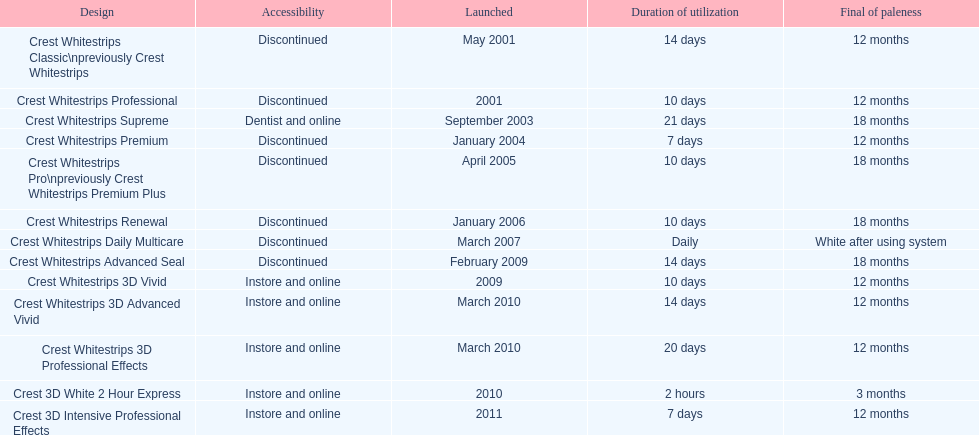What product was introduced in the same month as crest whitestrips 3d advanced vivid? Crest Whitestrips 3D Professional Effects. 